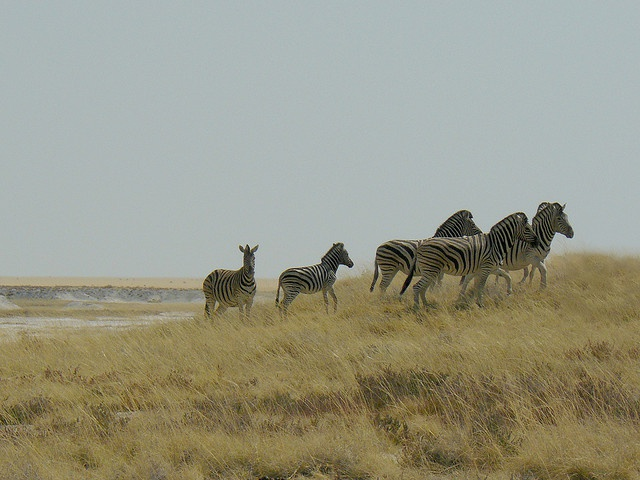Describe the objects in this image and their specific colors. I can see zebra in darkgray, black, gray, and darkgreen tones, zebra in darkgray, black, gray, darkgreen, and olive tones, zebra in darkgray, gray, black, and darkgreen tones, zebra in darkgray, olive, gray, and black tones, and zebra in darkgray, black, gray, darkgreen, and olive tones in this image. 